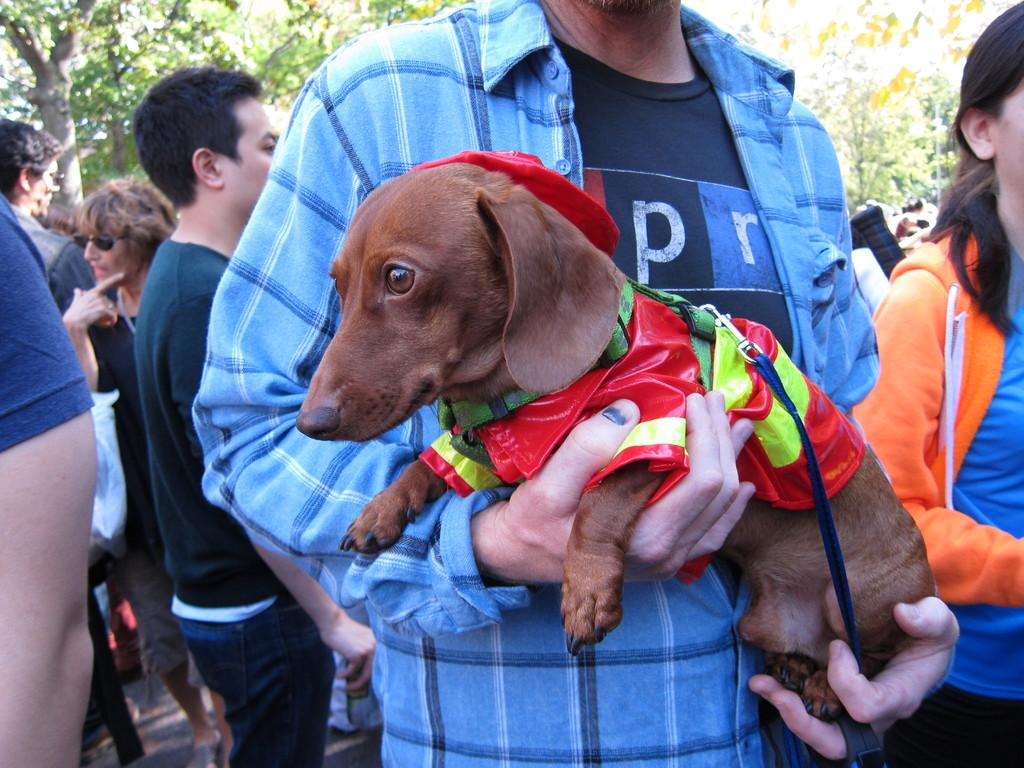What type of animal is in the image? There is a dog in the image. How is the dog dressed in the image? The dog is wearing a belt and a shirt. Who is holding the dog's shirt in the image? A person is holding the dog's shirt. What can be seen in the background of the image? There is a group of people and trees in the background of the image. What type of crack is visible in the image? There is no crack visible in the image. How does the air affect the dog's movement in the image? The image does not show the dog moving, and there is no information about the air's effect on the dog's movement. 